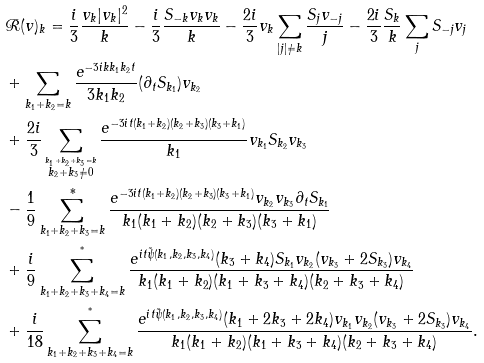Convert formula to latex. <formula><loc_0><loc_0><loc_500><loc_500>& \mathcal { R } ( v ) _ { k } = \frac { i } { 3 } \frac { v _ { k } | v _ { k } | ^ { 2 } } { k } - \frac { i } { 3 } \frac { S _ { - k } v _ { k } v _ { k } } { k } - \frac { 2 i } { 3 } v _ { k } \sum _ { | j | \neq k } \frac { S _ { j } v _ { - j } } { j } - \frac { 2 i } { 3 } \frac { S _ { k } } { k } \sum _ { j } S _ { - j } v _ { j } \\ & + \sum _ { k _ { 1 } + k _ { 2 } = k } \frac { e ^ { - 3 i k k _ { 1 } k _ { 2 } t } } { 3 k _ { 1 } k _ { 2 } } ( \partial _ { t } S _ { k _ { 1 } } ) v _ { k _ { 2 } } \\ & + \frac { 2 i } { 3 } \sum _ { \stackrel { k _ { 1 } + k _ { 2 } + k _ { 3 } = k } { k _ { 2 } + k _ { 3 } \neq 0 } } \frac { e ^ { - 3 i t ( k _ { 1 } + k _ { 2 } ) ( k _ { 2 } + k _ { 3 } ) ( k _ { 3 } + k _ { 1 } ) } } { k _ { 1 } } v _ { k _ { 1 } } S _ { k _ { 2 } } v _ { k _ { 3 } } \\ & - \frac { 1 } { 9 } \sum _ { k _ { 1 } + k _ { 2 } + k _ { 3 } = k } ^ { * } \frac { e ^ { - 3 i t ( k _ { 1 } + k _ { 2 } ) ( k _ { 2 } + k _ { 3 } ) ( k _ { 3 } + k _ { 1 } ) } v _ { k _ { 2 } } v _ { k _ { 3 } } \partial _ { t } S _ { k _ { 1 } } } { k _ { 1 } ( k _ { 1 } + k _ { 2 } ) ( k _ { 2 } + k _ { 3 } ) ( k _ { 3 } + k _ { 1 } ) } \\ & + \frac { i } { 9 } \sum _ { k _ { 1 } + k _ { 2 } + k _ { 3 } + k _ { 4 } = k } ^ { ^ { * } } \frac { e ^ { i t \tilde { \psi } ( k _ { 1 } , k _ { 2 } , k _ { 3 } , k _ { 4 } ) } ( k _ { 3 } + k _ { 4 } ) S _ { k _ { 1 } } v _ { k _ { 2 } } ( v _ { k _ { 3 } } + 2 S _ { k _ { 3 } } ) v _ { k _ { 4 } } } { k _ { 1 } ( k _ { 1 } + k _ { 2 } ) ( k _ { 1 } + k _ { 3 } + k _ { 4 } ) ( k _ { 2 } + k _ { 3 } + k _ { 4 } ) } \\ & + \frac { i } { 1 8 } \sum _ { k _ { 1 } + k _ { 2 } + k _ { 3 } + k _ { 4 } = k } ^ { ^ { * } } \frac { e ^ { i t \tilde { \psi } ( k _ { 1 } , k _ { 2 } , k _ { 3 } , k _ { 4 } ) } ( k _ { 1 } + 2 k _ { 3 } + 2 k _ { 4 } ) v _ { k _ { 1 } } v _ { k _ { 2 } } ( v _ { k _ { 3 } } + 2 S _ { k _ { 3 } } ) v _ { k _ { 4 } } } { k _ { 1 } ( k _ { 1 } + k _ { 2 } ) ( k _ { 1 } + k _ { 3 } + k _ { 4 } ) ( k _ { 2 } + k _ { 3 } + k _ { 4 } ) } .</formula> 